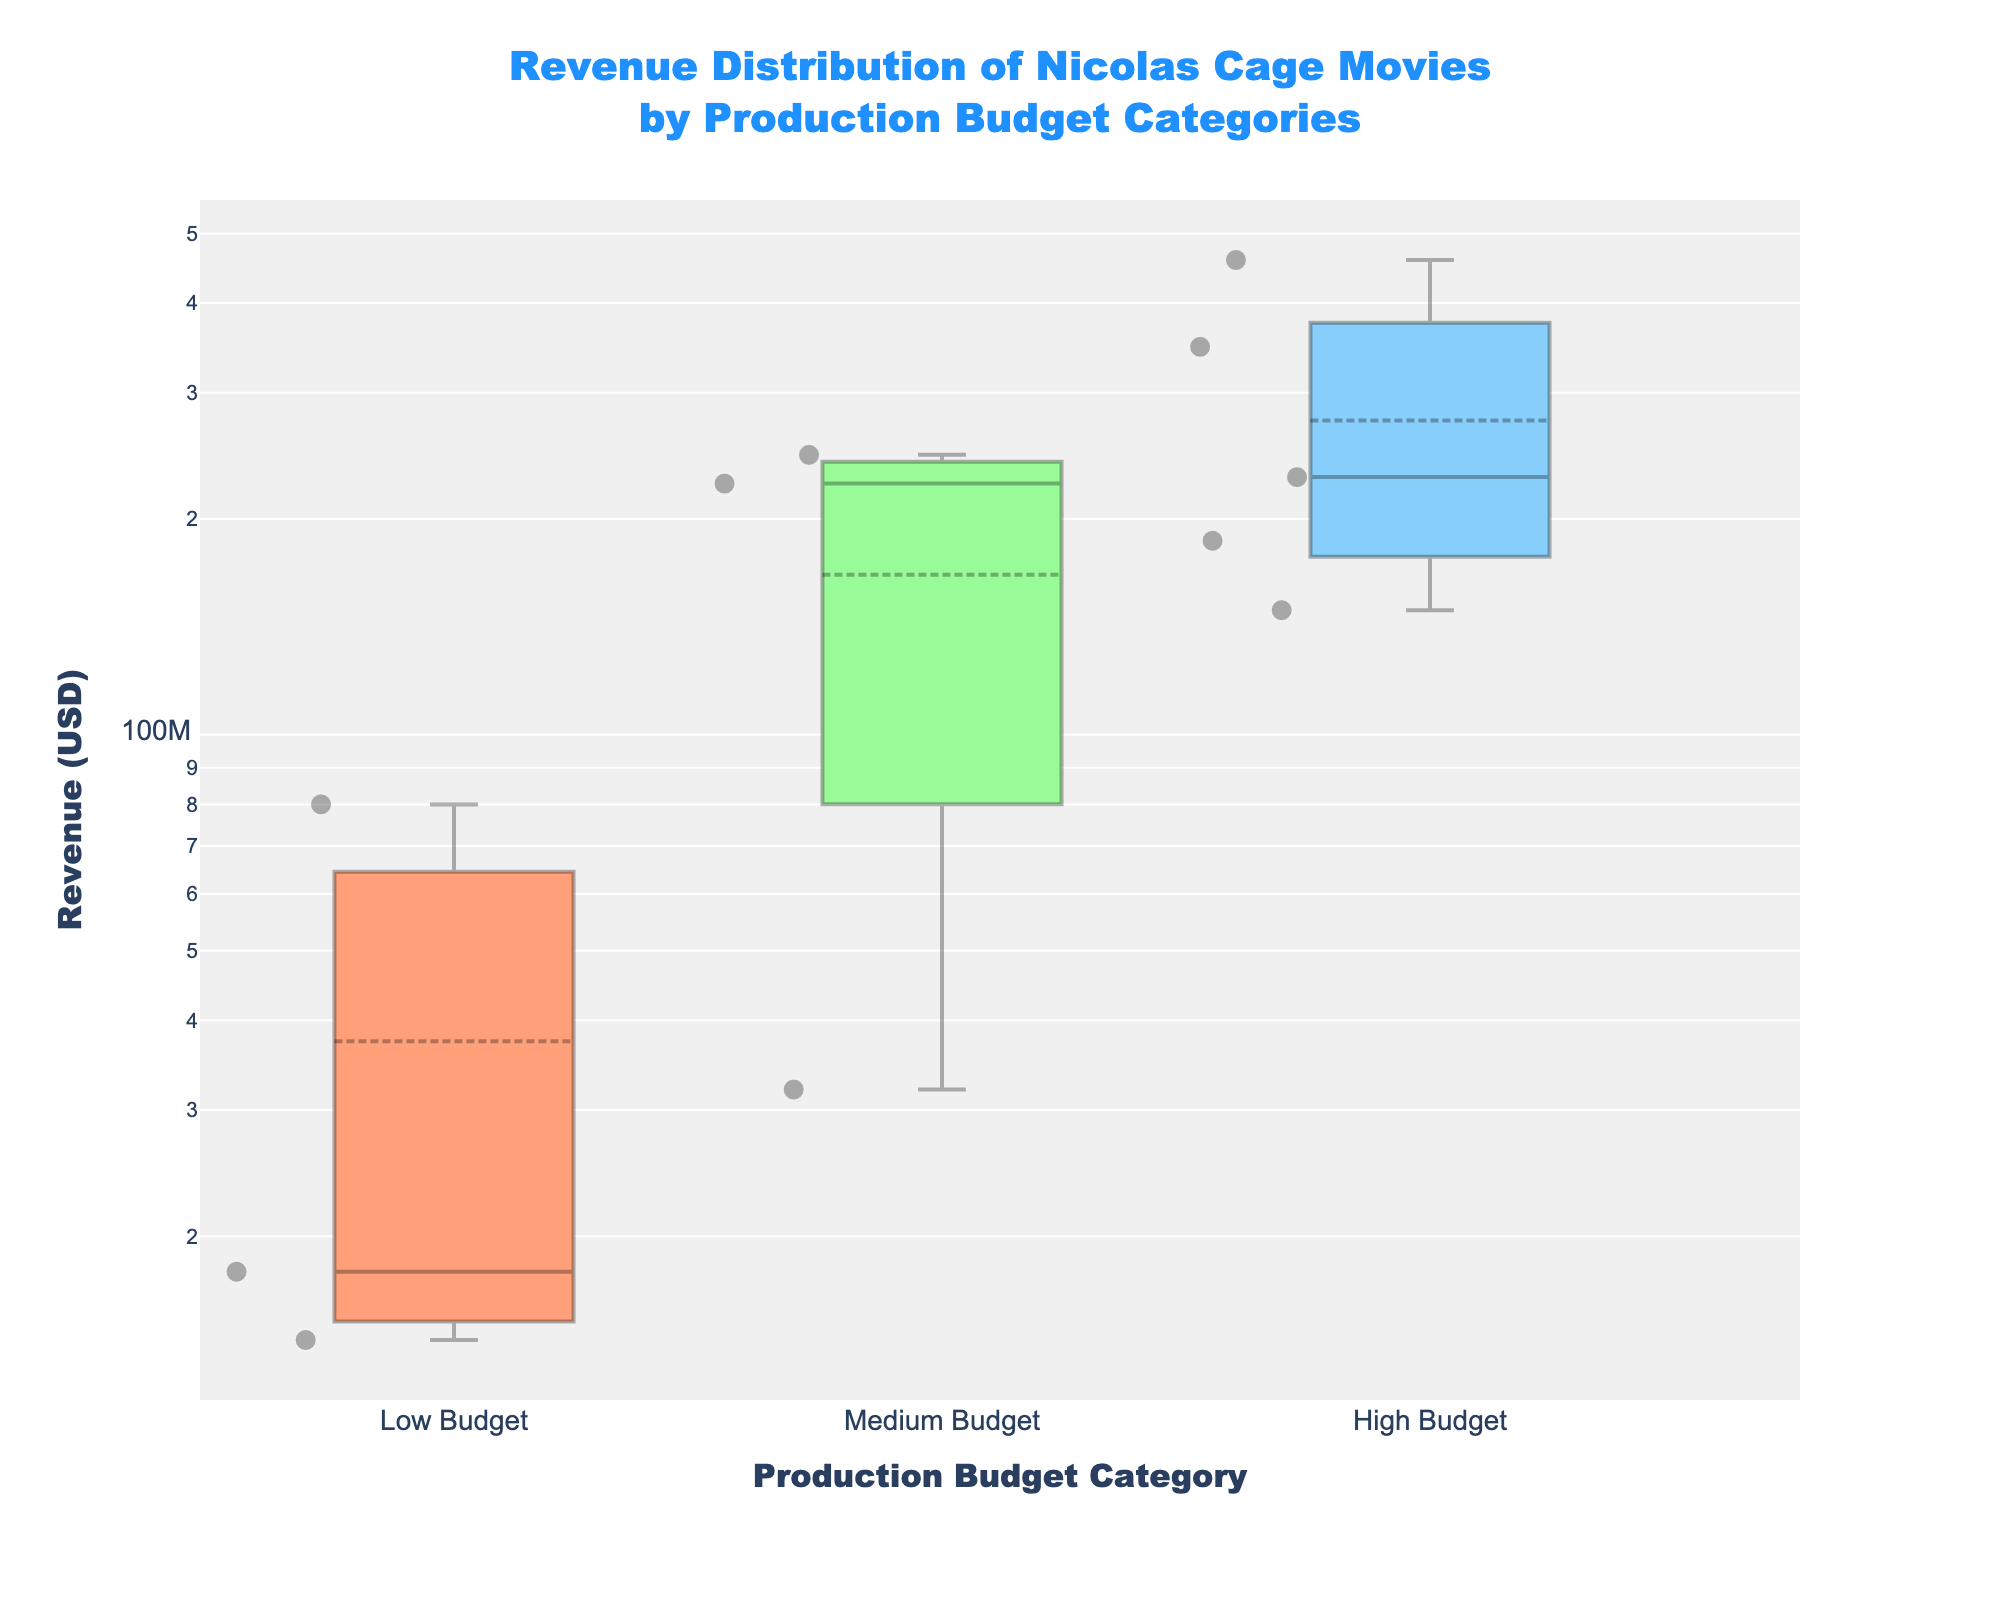How many production budget categories are displayed? The plot displays three production budget categories: "Low Budget," "Medium Budget," and "High Budget." You can count the distinct categories labeled on the x-axis.
Answer: Three What's the range of revenues for "Low Budget" movies? To determine the range, find the minimum and maximum revenue values for "Low Budget" movies on the y-axis. They span from around $17,843,399 to $80,000,000.
Answer: $17,843,399 - $80,000,000 Which production budget category has the highest median revenue? The median revenue is indicated by the line within each box. By comparing the boxes' median lines, "High Budget" movies have the highest median revenue.
Answer: High Budget What is the interquartile range (IQR) for "Medium Budget" movies? The IQR is the difference between the 75th percentile (Q3) and the 25th percentile (Q1). For "Medium Budget" movies, visually identify these quartiles as the edges of the box and subtract Q1 from Q3.
Answer: Approximately $180,646,506 (Note: exact values not Satisfied without data, estimated visually) Which individual movie has the highest revenue across all categories, and in which category does it belong? Find the highest point on the y-axis and its corresponding movie annotation. "National Treasure: Book of Secrets" in the "High Budget" category has the highest revenue at $459,240,992.
Answer: "National Treasure: Book of Secrets" in "High Budget" Compare the whisker lengths of "High Budget" and "Medium Budget" categories. Which category shows more variability? Whisker length indicates variability. By comparing the whisker lengths visually, "High Budget" appears to show more variability due to its longer whiskers.
Answer: High Budget What's the difference in the median revenue between "Low Budget" and "Medium Budget" movies? The median is the central line of each box. Subtract the median value of "Low Budget" from "Medium Budget." However, exact numbers should be read off directly.
Answer: Approximately $86,000,000 (calculation required for precision) In "Low Budget" movies, which movie title lies above the whisker? Annotations are given for data points above the whiskers. For "Low Budget," the movie "Moonstruck" is above the upper whisker.
Answer: Moonstruck What does the color coding represent in the plot? The colors distinguish different production budget categories. Each box is filled with a distinct color to visually separate "Low Budget," "Medium Budget," and "High Budget."
Answer: Different categories What can you infer about revenue trends with increasing production budgets from this plot? As production budgets increase from Low to High, the median, range, and upper whiskers of revenue also increase, suggesting higher budgets correlate with higher potential revenues.
Answer: Higher budgets correlate with higher revenues 